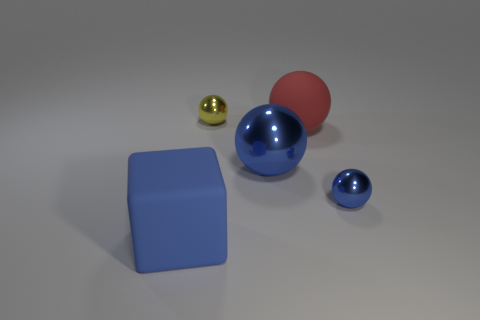Add 4 large yellow things. How many objects exist? 9 Subtract all cubes. How many objects are left? 4 Subtract all red metallic blocks. Subtract all tiny things. How many objects are left? 3 Add 5 tiny balls. How many tiny balls are left? 7 Add 2 tiny green metallic blocks. How many tiny green metallic blocks exist? 2 Subtract 0 cyan cylinders. How many objects are left? 5 